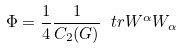Convert formula to latex. <formula><loc_0><loc_0><loc_500><loc_500>\Phi = \frac { 1 } { 4 } \frac { 1 } { C _ { 2 } ( G ) } \ t r W ^ { \alpha } W _ { \alpha }</formula> 